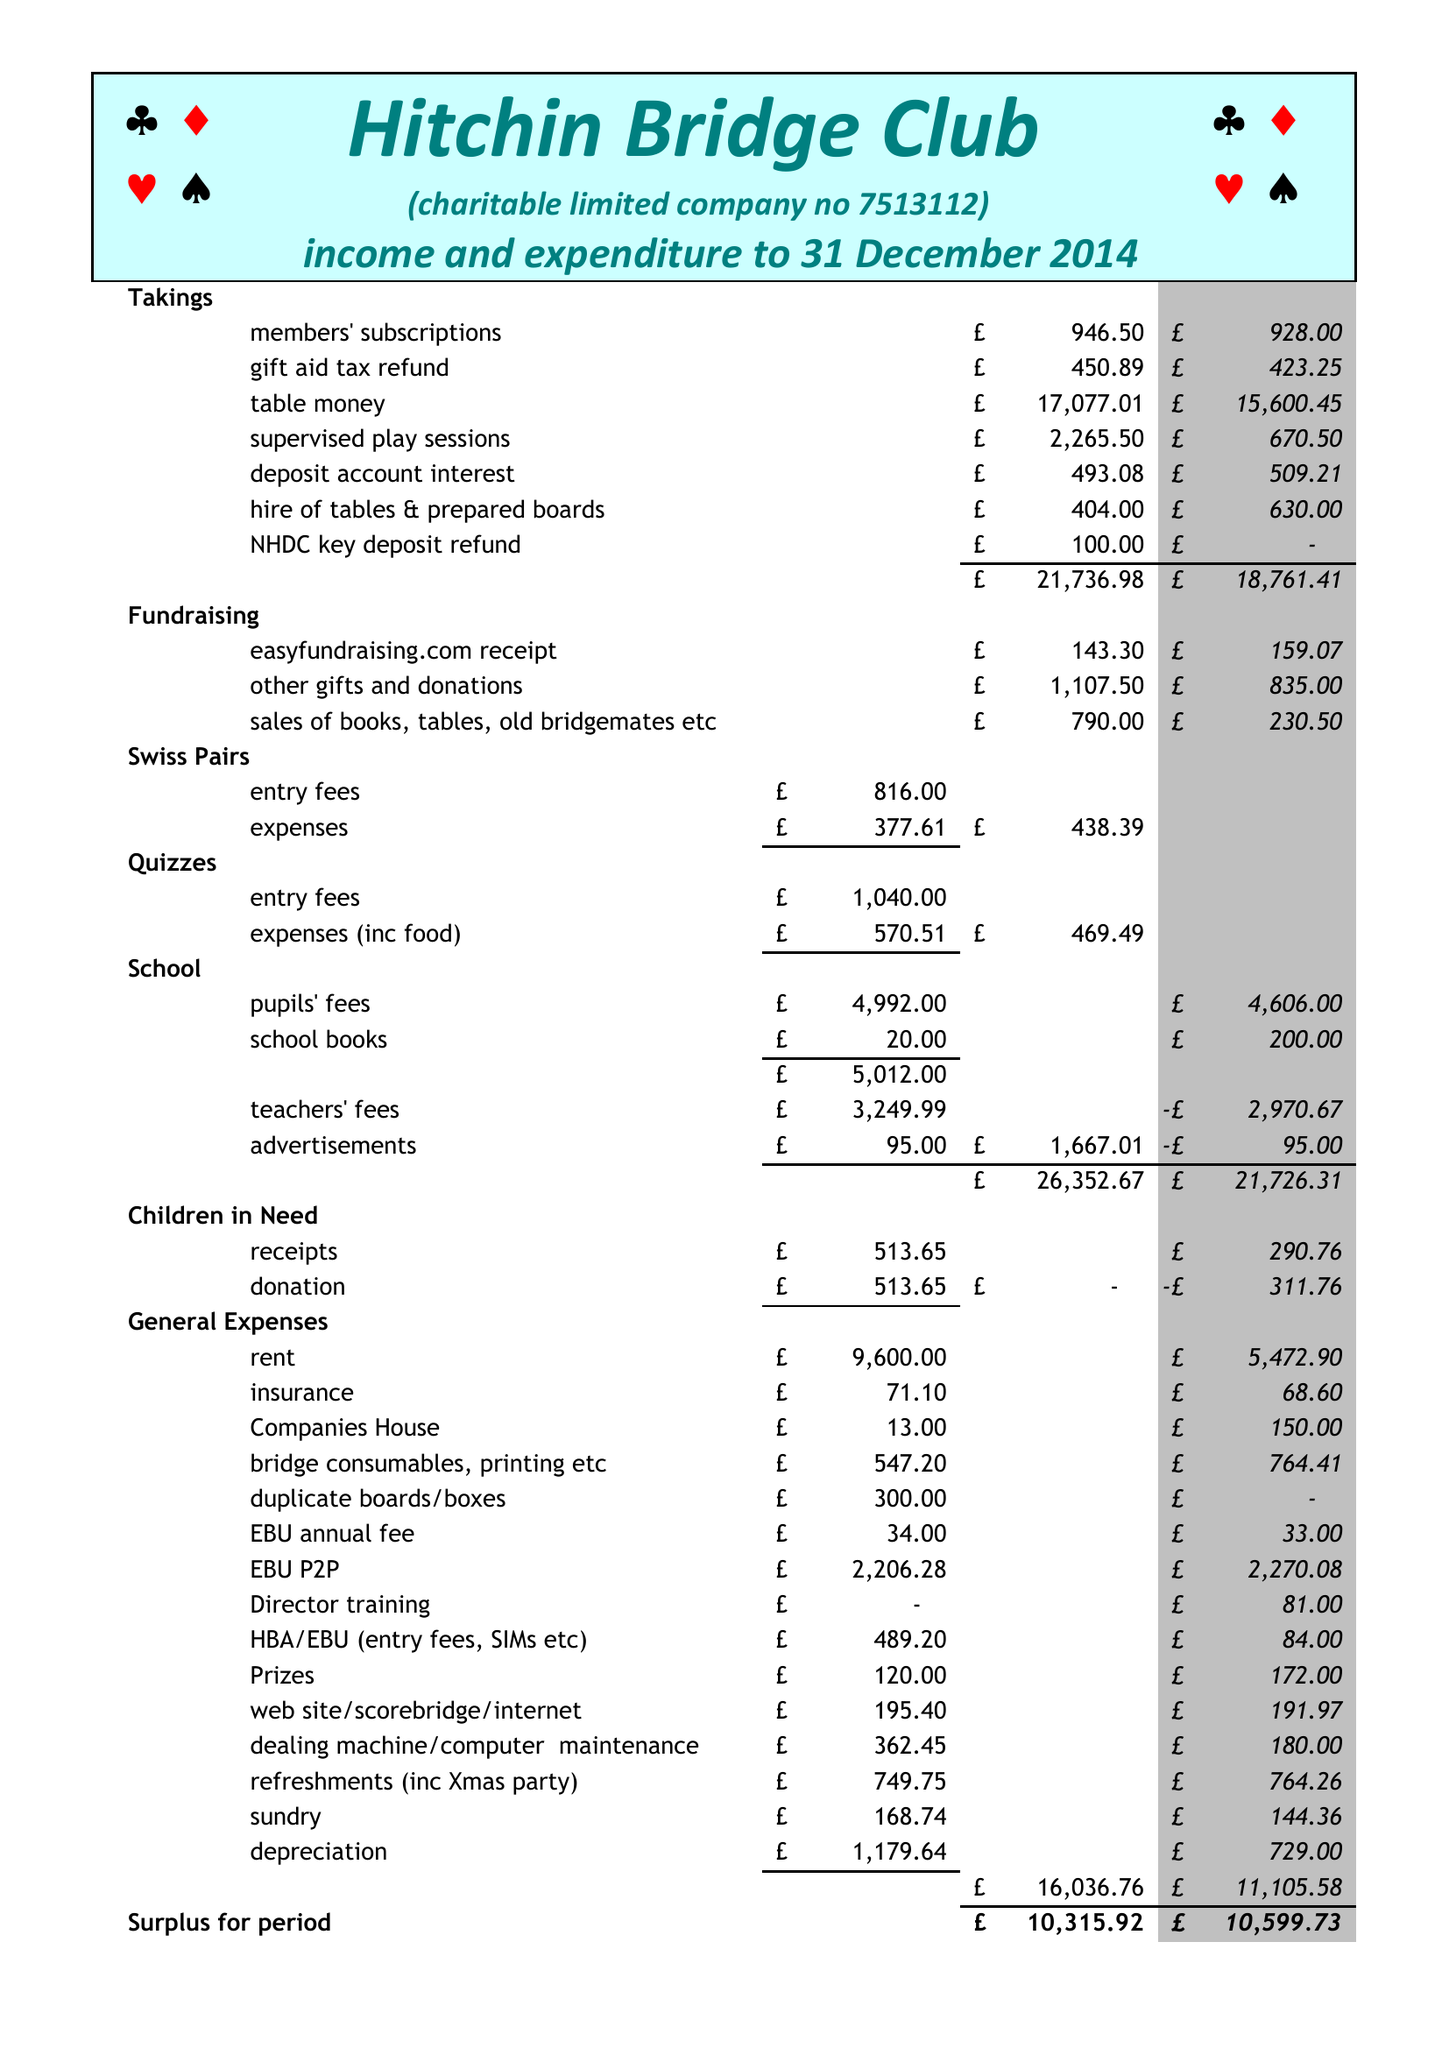What is the value for the spending_annually_in_british_pounds?
Answer the question using a single word or phrase. 16034.00 